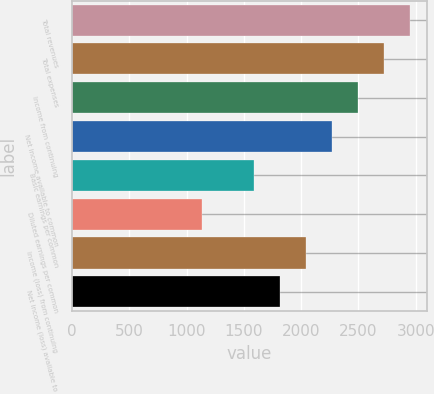Convert chart to OTSL. <chart><loc_0><loc_0><loc_500><loc_500><bar_chart><fcel>Total revenues<fcel>Total expenses<fcel>Income from continuing<fcel>Net income available to common<fcel>Basic earnings per common<fcel>Diluted earnings per common<fcel>Income (loss) from continuing<fcel>Net income (loss) available to<nl><fcel>2951.34<fcel>2724.34<fcel>2497.34<fcel>2270.34<fcel>1589.35<fcel>1135.35<fcel>2043.35<fcel>1816.35<nl></chart> 